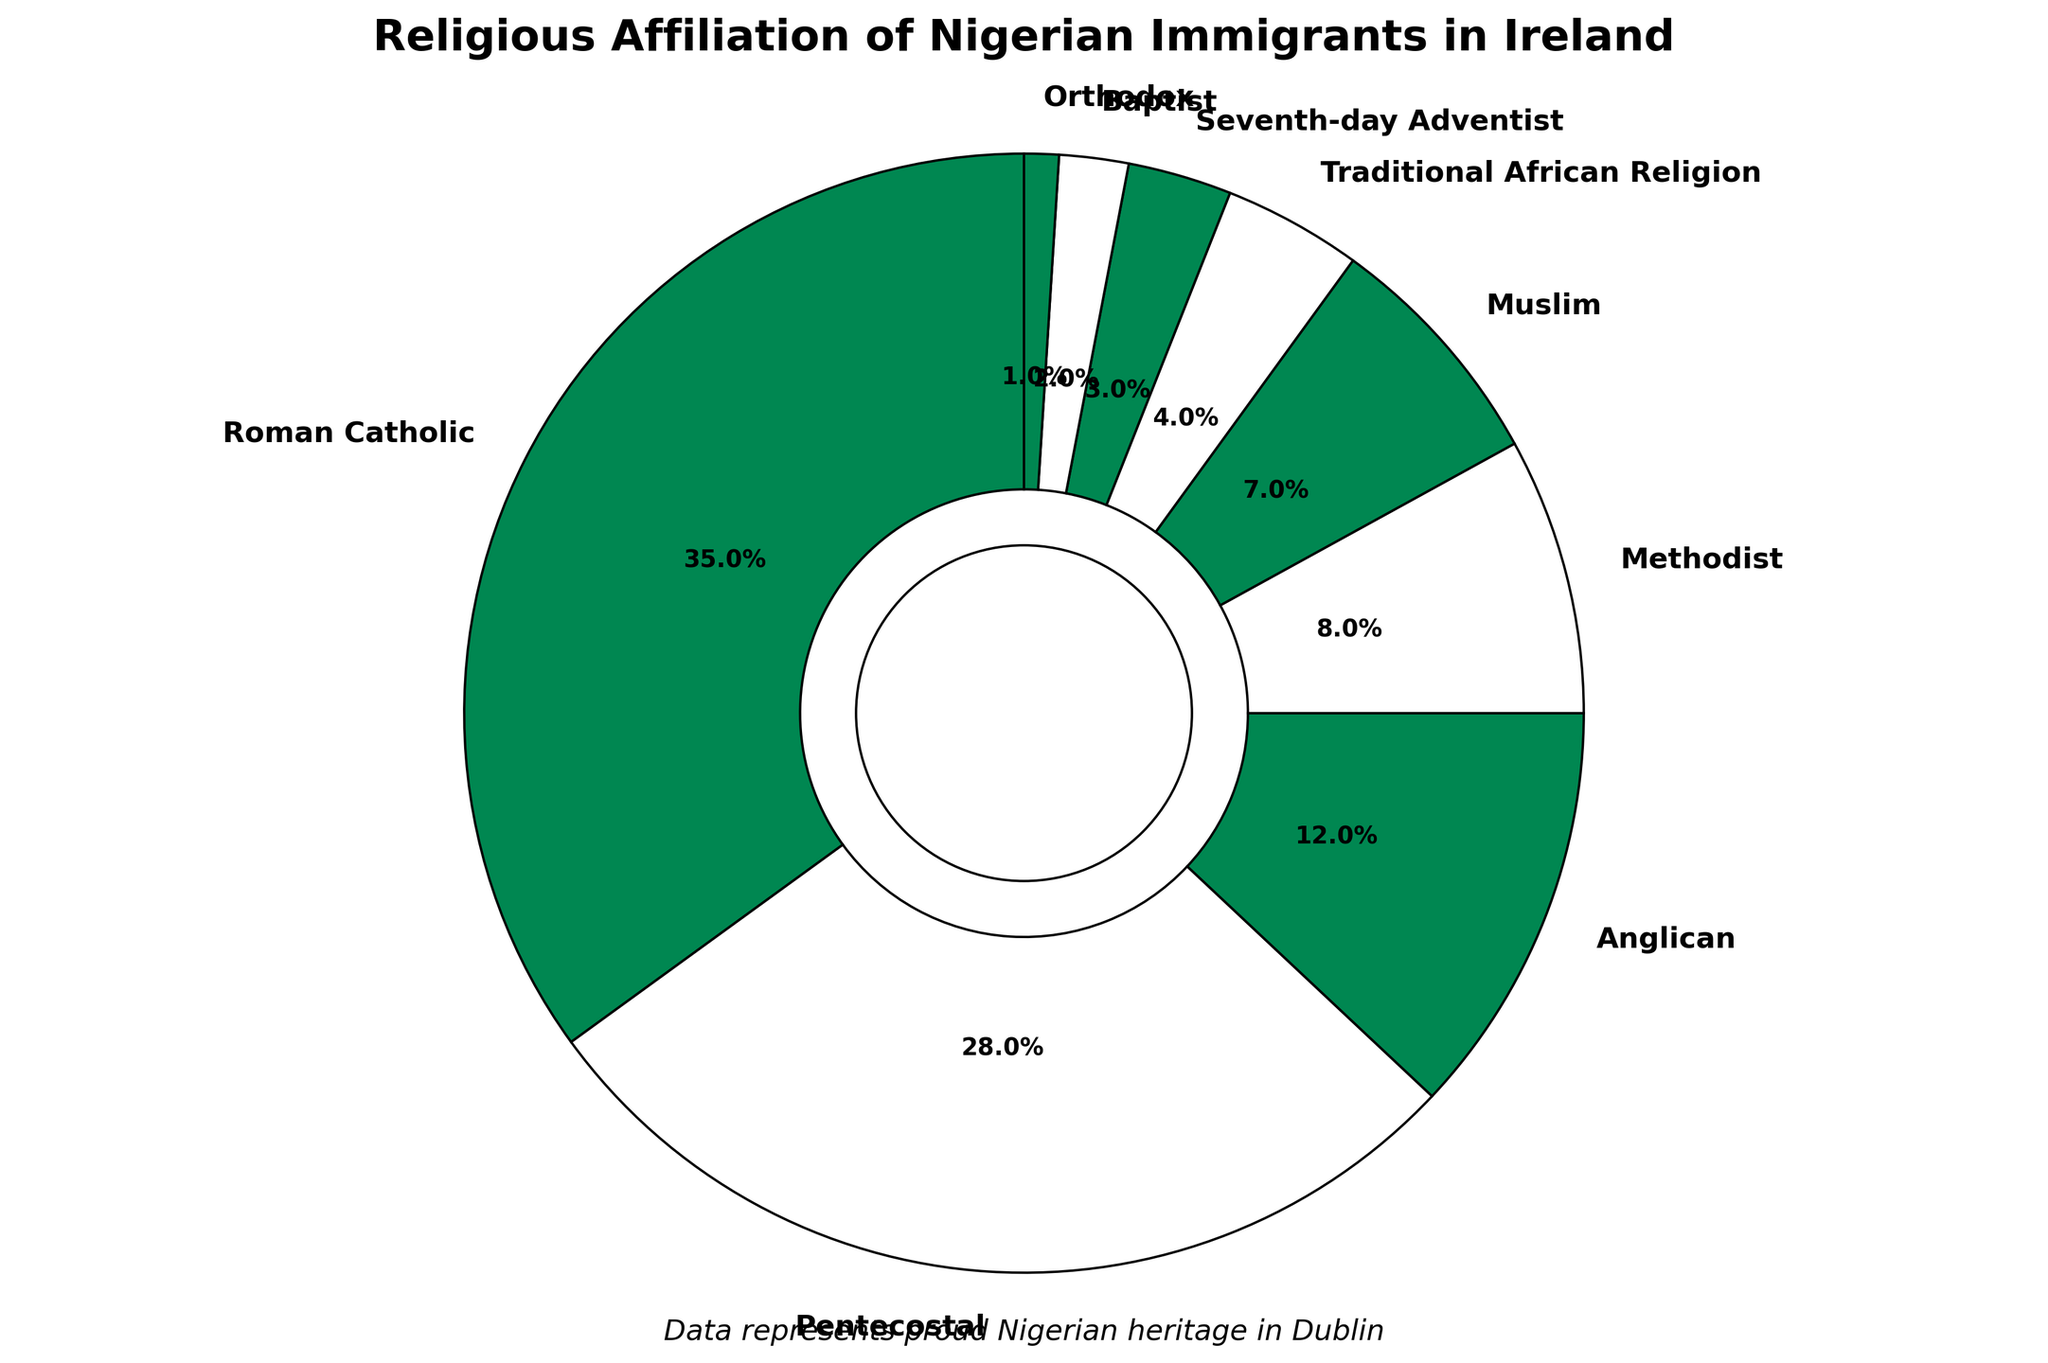Which religion has the highest percentage among Nigerian immigrants in Ireland? The pie chart shows that Roman Catholic holds the largest segment with a 35% share of the total religious affiliation.
Answer: Roman Catholic What's the combined percentage of Pentecostal and Anglican affiliations? Adding the percentages for Pentecostal (28%) and Anglican (12%) together gives 28% + 12% = 40%.
Answer: 40% How many religions have a percentage less than 10%? The religions with percentages less than 10% are Methodist, Muslim, Traditional African Religion, Seventh-day Adventist, Baptist, and Orthodox, totaling six religions.
Answer: 6 Which religions share the same color and what does that signify? Roman Catholic, Anglican, Traditional African Religion, and Orthodox all share the same green color, likely symbolizing the association with the colors of the Nigerian flag.
Answer: Roman Catholic, Anglican, Traditional African Religion, Orthodox What is the difference in percentage between the highest and the lowest represented religions? The highest percentage is Roman Catholic at 35%, and the lowest is Orthodox at 1%. The difference is 35% - 1% = 34%.
Answer: 34% Which is more popular among Nigerian immigrants in Ireland, Methodist or Muslim? The chart shows Methodist at 8% and Muslim at 7%. Methodist therefore has a slightly higher percentage.
Answer: Methodist What percentage of Nigerian immigrants practice Traditional African Religion, and how does it compare to the total percentage of Baptist and Orthodox combined? Traditional African Religion is at 4%. Baptist and Orthodox combined are 2% + 1% = 3%. Therefore, Traditional African Religion has a higher percentage.
Answer: Traditional African Religion has a higher percentage What percentage of the chart is represented by religions with a percentage less than or equal to 4%? Adding the percentages for Traditional African Religion (4%), Seventh-day Adventist (3%), Baptist (2%), and Orthodox (1%), the total is 4% + 3% + 2% + 1% = 10%.
Answer: 10% What color is used to represent the Pentecostal affiliation, and what could this color represent? The Pentecostal affiliation is represented by the white color, possibly signifying peace and purity.
Answer: White Is the proportion of Anglican affiliation greater than the combined proportion of Baptist and Orthodox? Anglican is 12%; Baptist and Orthodox together are 2% + 1% = 3%. Therefore, Anglican has a greater proportion.
Answer: Yes 